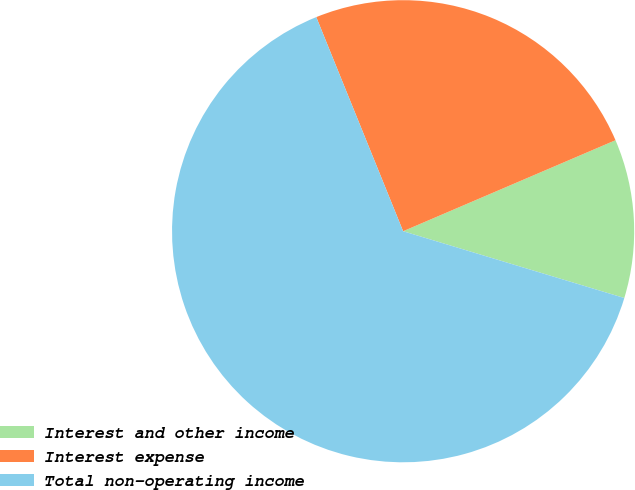Convert chart. <chart><loc_0><loc_0><loc_500><loc_500><pie_chart><fcel>Interest and other income<fcel>Interest expense<fcel>Total non-operating income<nl><fcel>11.11%<fcel>24.69%<fcel>64.2%<nl></chart> 